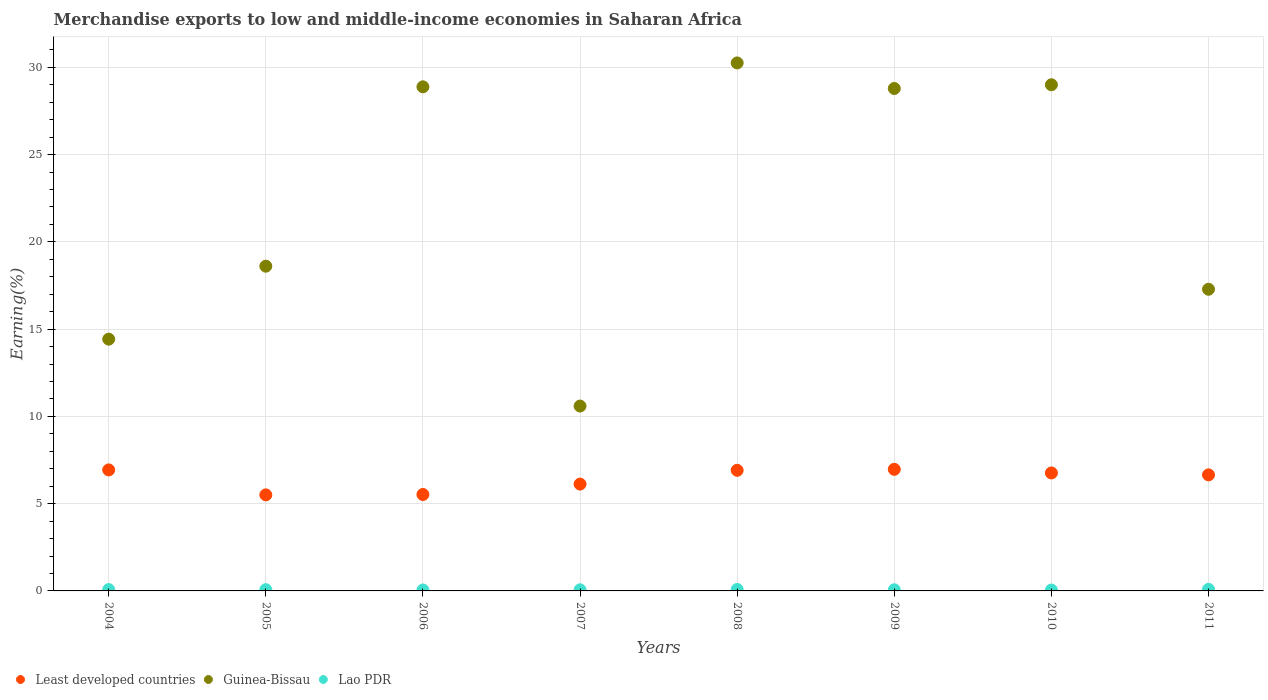What is the percentage of amount earned from merchandise exports in Least developed countries in 2004?
Keep it short and to the point. 6.93. Across all years, what is the maximum percentage of amount earned from merchandise exports in Least developed countries?
Your answer should be compact. 6.97. Across all years, what is the minimum percentage of amount earned from merchandise exports in Guinea-Bissau?
Give a very brief answer. 10.59. In which year was the percentage of amount earned from merchandise exports in Lao PDR minimum?
Your answer should be compact. 2010. What is the total percentage of amount earned from merchandise exports in Guinea-Bissau in the graph?
Your response must be concise. 177.85. What is the difference between the percentage of amount earned from merchandise exports in Least developed countries in 2005 and that in 2008?
Your response must be concise. -1.41. What is the difference between the percentage of amount earned from merchandise exports in Lao PDR in 2006 and the percentage of amount earned from merchandise exports in Least developed countries in 2011?
Provide a short and direct response. -6.6. What is the average percentage of amount earned from merchandise exports in Guinea-Bissau per year?
Your response must be concise. 22.23. In the year 2006, what is the difference between the percentage of amount earned from merchandise exports in Guinea-Bissau and percentage of amount earned from merchandise exports in Lao PDR?
Offer a terse response. 28.83. In how many years, is the percentage of amount earned from merchandise exports in Lao PDR greater than 1 %?
Keep it short and to the point. 0. What is the ratio of the percentage of amount earned from merchandise exports in Least developed countries in 2004 to that in 2006?
Offer a very short reply. 1.25. Is the percentage of amount earned from merchandise exports in Least developed countries in 2006 less than that in 2008?
Provide a succinct answer. Yes. What is the difference between the highest and the second highest percentage of amount earned from merchandise exports in Guinea-Bissau?
Provide a short and direct response. 1.25. What is the difference between the highest and the lowest percentage of amount earned from merchandise exports in Guinea-Bissau?
Give a very brief answer. 19.66. In how many years, is the percentage of amount earned from merchandise exports in Guinea-Bissau greater than the average percentage of amount earned from merchandise exports in Guinea-Bissau taken over all years?
Your answer should be very brief. 4. Does the percentage of amount earned from merchandise exports in Least developed countries monotonically increase over the years?
Ensure brevity in your answer.  No. How many years are there in the graph?
Keep it short and to the point. 8. What is the difference between two consecutive major ticks on the Y-axis?
Provide a short and direct response. 5. Are the values on the major ticks of Y-axis written in scientific E-notation?
Keep it short and to the point. No. Does the graph contain any zero values?
Provide a short and direct response. No. Where does the legend appear in the graph?
Offer a terse response. Bottom left. How many legend labels are there?
Provide a short and direct response. 3. What is the title of the graph?
Your response must be concise. Merchandise exports to low and middle-income economies in Saharan Africa. Does "Sub-Saharan Africa (developing only)" appear as one of the legend labels in the graph?
Your response must be concise. No. What is the label or title of the Y-axis?
Ensure brevity in your answer.  Earning(%). What is the Earning(%) of Least developed countries in 2004?
Make the answer very short. 6.93. What is the Earning(%) of Guinea-Bissau in 2004?
Your answer should be compact. 14.43. What is the Earning(%) of Lao PDR in 2004?
Provide a succinct answer. 0.08. What is the Earning(%) in Least developed countries in 2005?
Your answer should be compact. 5.5. What is the Earning(%) in Guinea-Bissau in 2005?
Your answer should be compact. 18.61. What is the Earning(%) of Lao PDR in 2005?
Offer a very short reply. 0.07. What is the Earning(%) of Least developed countries in 2006?
Your answer should be compact. 5.53. What is the Earning(%) of Guinea-Bissau in 2006?
Your answer should be compact. 28.89. What is the Earning(%) in Lao PDR in 2006?
Your answer should be very brief. 0.05. What is the Earning(%) in Least developed countries in 2007?
Provide a succinct answer. 6.12. What is the Earning(%) in Guinea-Bissau in 2007?
Give a very brief answer. 10.59. What is the Earning(%) in Lao PDR in 2007?
Make the answer very short. 0.06. What is the Earning(%) of Least developed countries in 2008?
Offer a very short reply. 6.91. What is the Earning(%) in Guinea-Bissau in 2008?
Your response must be concise. 30.25. What is the Earning(%) in Lao PDR in 2008?
Your response must be concise. 0.08. What is the Earning(%) of Least developed countries in 2009?
Your response must be concise. 6.97. What is the Earning(%) of Guinea-Bissau in 2009?
Make the answer very short. 28.79. What is the Earning(%) of Lao PDR in 2009?
Keep it short and to the point. 0.07. What is the Earning(%) of Least developed countries in 2010?
Your answer should be very brief. 6.76. What is the Earning(%) in Guinea-Bissau in 2010?
Offer a terse response. 29. What is the Earning(%) in Lao PDR in 2010?
Provide a succinct answer. 0.05. What is the Earning(%) in Least developed countries in 2011?
Give a very brief answer. 6.65. What is the Earning(%) of Guinea-Bissau in 2011?
Keep it short and to the point. 17.29. What is the Earning(%) of Lao PDR in 2011?
Make the answer very short. 0.09. Across all years, what is the maximum Earning(%) in Least developed countries?
Give a very brief answer. 6.97. Across all years, what is the maximum Earning(%) in Guinea-Bissau?
Provide a short and direct response. 30.25. Across all years, what is the maximum Earning(%) of Lao PDR?
Give a very brief answer. 0.09. Across all years, what is the minimum Earning(%) of Least developed countries?
Offer a terse response. 5.5. Across all years, what is the minimum Earning(%) of Guinea-Bissau?
Offer a very short reply. 10.59. Across all years, what is the minimum Earning(%) in Lao PDR?
Make the answer very short. 0.05. What is the total Earning(%) of Least developed countries in the graph?
Make the answer very short. 51.38. What is the total Earning(%) of Guinea-Bissau in the graph?
Make the answer very short. 177.85. What is the total Earning(%) of Lao PDR in the graph?
Offer a very short reply. 0.56. What is the difference between the Earning(%) in Least developed countries in 2004 and that in 2005?
Ensure brevity in your answer.  1.43. What is the difference between the Earning(%) in Guinea-Bissau in 2004 and that in 2005?
Keep it short and to the point. -4.18. What is the difference between the Earning(%) in Lao PDR in 2004 and that in 2005?
Your response must be concise. 0. What is the difference between the Earning(%) of Least developed countries in 2004 and that in 2006?
Your answer should be compact. 1.41. What is the difference between the Earning(%) of Guinea-Bissau in 2004 and that in 2006?
Ensure brevity in your answer.  -14.46. What is the difference between the Earning(%) in Lao PDR in 2004 and that in 2006?
Offer a very short reply. 0.02. What is the difference between the Earning(%) of Least developed countries in 2004 and that in 2007?
Your answer should be very brief. 0.81. What is the difference between the Earning(%) in Guinea-Bissau in 2004 and that in 2007?
Provide a succinct answer. 3.83. What is the difference between the Earning(%) in Lao PDR in 2004 and that in 2007?
Provide a succinct answer. 0.01. What is the difference between the Earning(%) in Least developed countries in 2004 and that in 2008?
Make the answer very short. 0.02. What is the difference between the Earning(%) of Guinea-Bissau in 2004 and that in 2008?
Your answer should be very brief. -15.83. What is the difference between the Earning(%) in Lao PDR in 2004 and that in 2008?
Make the answer very short. -0.01. What is the difference between the Earning(%) of Least developed countries in 2004 and that in 2009?
Give a very brief answer. -0.03. What is the difference between the Earning(%) in Guinea-Bissau in 2004 and that in 2009?
Your answer should be compact. -14.36. What is the difference between the Earning(%) in Lao PDR in 2004 and that in 2009?
Your answer should be compact. 0.01. What is the difference between the Earning(%) in Least developed countries in 2004 and that in 2010?
Give a very brief answer. 0.17. What is the difference between the Earning(%) of Guinea-Bissau in 2004 and that in 2010?
Your answer should be compact. -14.58. What is the difference between the Earning(%) in Lao PDR in 2004 and that in 2010?
Keep it short and to the point. 0.03. What is the difference between the Earning(%) in Least developed countries in 2004 and that in 2011?
Keep it short and to the point. 0.28. What is the difference between the Earning(%) of Guinea-Bissau in 2004 and that in 2011?
Your answer should be compact. -2.86. What is the difference between the Earning(%) of Lao PDR in 2004 and that in 2011?
Ensure brevity in your answer.  -0.01. What is the difference between the Earning(%) in Least developed countries in 2005 and that in 2006?
Offer a terse response. -0.02. What is the difference between the Earning(%) of Guinea-Bissau in 2005 and that in 2006?
Ensure brevity in your answer.  -10.28. What is the difference between the Earning(%) of Lao PDR in 2005 and that in 2006?
Provide a short and direct response. 0.02. What is the difference between the Earning(%) in Least developed countries in 2005 and that in 2007?
Your response must be concise. -0.62. What is the difference between the Earning(%) of Guinea-Bissau in 2005 and that in 2007?
Your answer should be very brief. 8.01. What is the difference between the Earning(%) in Lao PDR in 2005 and that in 2007?
Give a very brief answer. 0.01. What is the difference between the Earning(%) of Least developed countries in 2005 and that in 2008?
Make the answer very short. -1.41. What is the difference between the Earning(%) in Guinea-Bissau in 2005 and that in 2008?
Make the answer very short. -11.65. What is the difference between the Earning(%) of Lao PDR in 2005 and that in 2008?
Keep it short and to the point. -0.01. What is the difference between the Earning(%) of Least developed countries in 2005 and that in 2009?
Ensure brevity in your answer.  -1.46. What is the difference between the Earning(%) of Guinea-Bissau in 2005 and that in 2009?
Your response must be concise. -10.18. What is the difference between the Earning(%) of Lao PDR in 2005 and that in 2009?
Offer a terse response. 0.01. What is the difference between the Earning(%) in Least developed countries in 2005 and that in 2010?
Offer a very short reply. -1.26. What is the difference between the Earning(%) in Guinea-Bissau in 2005 and that in 2010?
Your response must be concise. -10.4. What is the difference between the Earning(%) of Lao PDR in 2005 and that in 2010?
Make the answer very short. 0.02. What is the difference between the Earning(%) of Least developed countries in 2005 and that in 2011?
Offer a terse response. -1.15. What is the difference between the Earning(%) of Guinea-Bissau in 2005 and that in 2011?
Ensure brevity in your answer.  1.32. What is the difference between the Earning(%) of Lao PDR in 2005 and that in 2011?
Provide a succinct answer. -0.02. What is the difference between the Earning(%) of Least developed countries in 2006 and that in 2007?
Keep it short and to the point. -0.6. What is the difference between the Earning(%) of Guinea-Bissau in 2006 and that in 2007?
Offer a very short reply. 18.29. What is the difference between the Earning(%) of Lao PDR in 2006 and that in 2007?
Keep it short and to the point. -0.01. What is the difference between the Earning(%) of Least developed countries in 2006 and that in 2008?
Your answer should be very brief. -1.39. What is the difference between the Earning(%) of Guinea-Bissau in 2006 and that in 2008?
Your answer should be very brief. -1.37. What is the difference between the Earning(%) in Lao PDR in 2006 and that in 2008?
Your answer should be compact. -0.03. What is the difference between the Earning(%) of Least developed countries in 2006 and that in 2009?
Offer a very short reply. -1.44. What is the difference between the Earning(%) in Guinea-Bissau in 2006 and that in 2009?
Ensure brevity in your answer.  0.09. What is the difference between the Earning(%) in Lao PDR in 2006 and that in 2009?
Your response must be concise. -0.01. What is the difference between the Earning(%) in Least developed countries in 2006 and that in 2010?
Make the answer very short. -1.23. What is the difference between the Earning(%) of Guinea-Bissau in 2006 and that in 2010?
Ensure brevity in your answer.  -0.12. What is the difference between the Earning(%) in Lao PDR in 2006 and that in 2010?
Give a very brief answer. 0. What is the difference between the Earning(%) in Least developed countries in 2006 and that in 2011?
Your response must be concise. -1.12. What is the difference between the Earning(%) of Guinea-Bissau in 2006 and that in 2011?
Your response must be concise. 11.6. What is the difference between the Earning(%) in Lao PDR in 2006 and that in 2011?
Ensure brevity in your answer.  -0.04. What is the difference between the Earning(%) of Least developed countries in 2007 and that in 2008?
Provide a short and direct response. -0.79. What is the difference between the Earning(%) of Guinea-Bissau in 2007 and that in 2008?
Your answer should be very brief. -19.66. What is the difference between the Earning(%) in Lao PDR in 2007 and that in 2008?
Your answer should be very brief. -0.02. What is the difference between the Earning(%) in Least developed countries in 2007 and that in 2009?
Keep it short and to the point. -0.85. What is the difference between the Earning(%) in Guinea-Bissau in 2007 and that in 2009?
Offer a very short reply. -18.2. What is the difference between the Earning(%) in Lao PDR in 2007 and that in 2009?
Offer a very short reply. -0. What is the difference between the Earning(%) of Least developed countries in 2007 and that in 2010?
Provide a succinct answer. -0.64. What is the difference between the Earning(%) in Guinea-Bissau in 2007 and that in 2010?
Offer a terse response. -18.41. What is the difference between the Earning(%) in Lao PDR in 2007 and that in 2010?
Offer a very short reply. 0.01. What is the difference between the Earning(%) in Least developed countries in 2007 and that in 2011?
Keep it short and to the point. -0.53. What is the difference between the Earning(%) of Guinea-Bissau in 2007 and that in 2011?
Give a very brief answer. -6.69. What is the difference between the Earning(%) of Lao PDR in 2007 and that in 2011?
Provide a short and direct response. -0.03. What is the difference between the Earning(%) in Least developed countries in 2008 and that in 2009?
Keep it short and to the point. -0.06. What is the difference between the Earning(%) of Guinea-Bissau in 2008 and that in 2009?
Offer a terse response. 1.46. What is the difference between the Earning(%) in Lao PDR in 2008 and that in 2009?
Ensure brevity in your answer.  0.02. What is the difference between the Earning(%) of Least developed countries in 2008 and that in 2010?
Offer a very short reply. 0.15. What is the difference between the Earning(%) of Guinea-Bissau in 2008 and that in 2010?
Ensure brevity in your answer.  1.25. What is the difference between the Earning(%) of Lao PDR in 2008 and that in 2010?
Your answer should be compact. 0.03. What is the difference between the Earning(%) in Least developed countries in 2008 and that in 2011?
Your answer should be very brief. 0.26. What is the difference between the Earning(%) in Guinea-Bissau in 2008 and that in 2011?
Give a very brief answer. 12.97. What is the difference between the Earning(%) of Lao PDR in 2008 and that in 2011?
Provide a short and direct response. -0.01. What is the difference between the Earning(%) of Least developed countries in 2009 and that in 2010?
Your answer should be compact. 0.21. What is the difference between the Earning(%) of Guinea-Bissau in 2009 and that in 2010?
Ensure brevity in your answer.  -0.21. What is the difference between the Earning(%) of Lao PDR in 2009 and that in 2010?
Your response must be concise. 0.02. What is the difference between the Earning(%) of Least developed countries in 2009 and that in 2011?
Offer a very short reply. 0.32. What is the difference between the Earning(%) of Guinea-Bissau in 2009 and that in 2011?
Keep it short and to the point. 11.5. What is the difference between the Earning(%) in Lao PDR in 2009 and that in 2011?
Provide a short and direct response. -0.03. What is the difference between the Earning(%) in Least developed countries in 2010 and that in 2011?
Your answer should be very brief. 0.11. What is the difference between the Earning(%) in Guinea-Bissau in 2010 and that in 2011?
Your answer should be compact. 11.72. What is the difference between the Earning(%) in Lao PDR in 2010 and that in 2011?
Your answer should be very brief. -0.04. What is the difference between the Earning(%) of Least developed countries in 2004 and the Earning(%) of Guinea-Bissau in 2005?
Your answer should be compact. -11.67. What is the difference between the Earning(%) in Least developed countries in 2004 and the Earning(%) in Lao PDR in 2005?
Your answer should be very brief. 6.86. What is the difference between the Earning(%) of Guinea-Bissau in 2004 and the Earning(%) of Lao PDR in 2005?
Keep it short and to the point. 14.35. What is the difference between the Earning(%) in Least developed countries in 2004 and the Earning(%) in Guinea-Bissau in 2006?
Provide a succinct answer. -21.95. What is the difference between the Earning(%) of Least developed countries in 2004 and the Earning(%) of Lao PDR in 2006?
Make the answer very short. 6.88. What is the difference between the Earning(%) in Guinea-Bissau in 2004 and the Earning(%) in Lao PDR in 2006?
Give a very brief answer. 14.37. What is the difference between the Earning(%) in Least developed countries in 2004 and the Earning(%) in Guinea-Bissau in 2007?
Give a very brief answer. -3.66. What is the difference between the Earning(%) of Least developed countries in 2004 and the Earning(%) of Lao PDR in 2007?
Offer a very short reply. 6.87. What is the difference between the Earning(%) of Guinea-Bissau in 2004 and the Earning(%) of Lao PDR in 2007?
Ensure brevity in your answer.  14.36. What is the difference between the Earning(%) of Least developed countries in 2004 and the Earning(%) of Guinea-Bissau in 2008?
Make the answer very short. -23.32. What is the difference between the Earning(%) in Least developed countries in 2004 and the Earning(%) in Lao PDR in 2008?
Your answer should be very brief. 6.85. What is the difference between the Earning(%) of Guinea-Bissau in 2004 and the Earning(%) of Lao PDR in 2008?
Make the answer very short. 14.34. What is the difference between the Earning(%) in Least developed countries in 2004 and the Earning(%) in Guinea-Bissau in 2009?
Ensure brevity in your answer.  -21.86. What is the difference between the Earning(%) in Least developed countries in 2004 and the Earning(%) in Lao PDR in 2009?
Offer a very short reply. 6.87. What is the difference between the Earning(%) in Guinea-Bissau in 2004 and the Earning(%) in Lao PDR in 2009?
Ensure brevity in your answer.  14.36. What is the difference between the Earning(%) of Least developed countries in 2004 and the Earning(%) of Guinea-Bissau in 2010?
Your response must be concise. -22.07. What is the difference between the Earning(%) in Least developed countries in 2004 and the Earning(%) in Lao PDR in 2010?
Provide a succinct answer. 6.88. What is the difference between the Earning(%) of Guinea-Bissau in 2004 and the Earning(%) of Lao PDR in 2010?
Your response must be concise. 14.38. What is the difference between the Earning(%) of Least developed countries in 2004 and the Earning(%) of Guinea-Bissau in 2011?
Your answer should be very brief. -10.35. What is the difference between the Earning(%) in Least developed countries in 2004 and the Earning(%) in Lao PDR in 2011?
Offer a very short reply. 6.84. What is the difference between the Earning(%) in Guinea-Bissau in 2004 and the Earning(%) in Lao PDR in 2011?
Provide a short and direct response. 14.34. What is the difference between the Earning(%) of Least developed countries in 2005 and the Earning(%) of Guinea-Bissau in 2006?
Your response must be concise. -23.38. What is the difference between the Earning(%) of Least developed countries in 2005 and the Earning(%) of Lao PDR in 2006?
Your response must be concise. 5.45. What is the difference between the Earning(%) in Guinea-Bissau in 2005 and the Earning(%) in Lao PDR in 2006?
Provide a short and direct response. 18.55. What is the difference between the Earning(%) in Least developed countries in 2005 and the Earning(%) in Guinea-Bissau in 2007?
Your response must be concise. -5.09. What is the difference between the Earning(%) of Least developed countries in 2005 and the Earning(%) of Lao PDR in 2007?
Your answer should be compact. 5.44. What is the difference between the Earning(%) of Guinea-Bissau in 2005 and the Earning(%) of Lao PDR in 2007?
Your answer should be compact. 18.54. What is the difference between the Earning(%) of Least developed countries in 2005 and the Earning(%) of Guinea-Bissau in 2008?
Your response must be concise. -24.75. What is the difference between the Earning(%) in Least developed countries in 2005 and the Earning(%) in Lao PDR in 2008?
Your response must be concise. 5.42. What is the difference between the Earning(%) in Guinea-Bissau in 2005 and the Earning(%) in Lao PDR in 2008?
Offer a very short reply. 18.52. What is the difference between the Earning(%) of Least developed countries in 2005 and the Earning(%) of Guinea-Bissau in 2009?
Offer a very short reply. -23.29. What is the difference between the Earning(%) of Least developed countries in 2005 and the Earning(%) of Lao PDR in 2009?
Ensure brevity in your answer.  5.44. What is the difference between the Earning(%) of Guinea-Bissau in 2005 and the Earning(%) of Lao PDR in 2009?
Your answer should be very brief. 18.54. What is the difference between the Earning(%) in Least developed countries in 2005 and the Earning(%) in Guinea-Bissau in 2010?
Your answer should be very brief. -23.5. What is the difference between the Earning(%) of Least developed countries in 2005 and the Earning(%) of Lao PDR in 2010?
Make the answer very short. 5.45. What is the difference between the Earning(%) in Guinea-Bissau in 2005 and the Earning(%) in Lao PDR in 2010?
Your answer should be very brief. 18.56. What is the difference between the Earning(%) in Least developed countries in 2005 and the Earning(%) in Guinea-Bissau in 2011?
Give a very brief answer. -11.78. What is the difference between the Earning(%) of Least developed countries in 2005 and the Earning(%) of Lao PDR in 2011?
Provide a succinct answer. 5.41. What is the difference between the Earning(%) in Guinea-Bissau in 2005 and the Earning(%) in Lao PDR in 2011?
Your answer should be compact. 18.52. What is the difference between the Earning(%) in Least developed countries in 2006 and the Earning(%) in Guinea-Bissau in 2007?
Provide a short and direct response. -5.07. What is the difference between the Earning(%) in Least developed countries in 2006 and the Earning(%) in Lao PDR in 2007?
Keep it short and to the point. 5.46. What is the difference between the Earning(%) in Guinea-Bissau in 2006 and the Earning(%) in Lao PDR in 2007?
Your answer should be very brief. 28.82. What is the difference between the Earning(%) of Least developed countries in 2006 and the Earning(%) of Guinea-Bissau in 2008?
Your response must be concise. -24.73. What is the difference between the Earning(%) of Least developed countries in 2006 and the Earning(%) of Lao PDR in 2008?
Offer a very short reply. 5.44. What is the difference between the Earning(%) in Guinea-Bissau in 2006 and the Earning(%) in Lao PDR in 2008?
Your response must be concise. 28.8. What is the difference between the Earning(%) of Least developed countries in 2006 and the Earning(%) of Guinea-Bissau in 2009?
Your answer should be compact. -23.27. What is the difference between the Earning(%) of Least developed countries in 2006 and the Earning(%) of Lao PDR in 2009?
Your response must be concise. 5.46. What is the difference between the Earning(%) of Guinea-Bissau in 2006 and the Earning(%) of Lao PDR in 2009?
Provide a short and direct response. 28.82. What is the difference between the Earning(%) of Least developed countries in 2006 and the Earning(%) of Guinea-Bissau in 2010?
Provide a succinct answer. -23.48. What is the difference between the Earning(%) of Least developed countries in 2006 and the Earning(%) of Lao PDR in 2010?
Provide a short and direct response. 5.48. What is the difference between the Earning(%) in Guinea-Bissau in 2006 and the Earning(%) in Lao PDR in 2010?
Your answer should be very brief. 28.83. What is the difference between the Earning(%) of Least developed countries in 2006 and the Earning(%) of Guinea-Bissau in 2011?
Your answer should be compact. -11.76. What is the difference between the Earning(%) in Least developed countries in 2006 and the Earning(%) in Lao PDR in 2011?
Your answer should be compact. 5.43. What is the difference between the Earning(%) of Guinea-Bissau in 2006 and the Earning(%) of Lao PDR in 2011?
Your answer should be very brief. 28.79. What is the difference between the Earning(%) in Least developed countries in 2007 and the Earning(%) in Guinea-Bissau in 2008?
Offer a very short reply. -24.13. What is the difference between the Earning(%) of Least developed countries in 2007 and the Earning(%) of Lao PDR in 2008?
Offer a very short reply. 6.04. What is the difference between the Earning(%) of Guinea-Bissau in 2007 and the Earning(%) of Lao PDR in 2008?
Make the answer very short. 10.51. What is the difference between the Earning(%) of Least developed countries in 2007 and the Earning(%) of Guinea-Bissau in 2009?
Give a very brief answer. -22.67. What is the difference between the Earning(%) in Least developed countries in 2007 and the Earning(%) in Lao PDR in 2009?
Ensure brevity in your answer.  6.06. What is the difference between the Earning(%) in Guinea-Bissau in 2007 and the Earning(%) in Lao PDR in 2009?
Your answer should be very brief. 10.53. What is the difference between the Earning(%) of Least developed countries in 2007 and the Earning(%) of Guinea-Bissau in 2010?
Provide a short and direct response. -22.88. What is the difference between the Earning(%) in Least developed countries in 2007 and the Earning(%) in Lao PDR in 2010?
Provide a succinct answer. 6.07. What is the difference between the Earning(%) in Guinea-Bissau in 2007 and the Earning(%) in Lao PDR in 2010?
Your answer should be very brief. 10.54. What is the difference between the Earning(%) of Least developed countries in 2007 and the Earning(%) of Guinea-Bissau in 2011?
Your answer should be compact. -11.16. What is the difference between the Earning(%) of Least developed countries in 2007 and the Earning(%) of Lao PDR in 2011?
Provide a succinct answer. 6.03. What is the difference between the Earning(%) in Guinea-Bissau in 2007 and the Earning(%) in Lao PDR in 2011?
Provide a short and direct response. 10.5. What is the difference between the Earning(%) in Least developed countries in 2008 and the Earning(%) in Guinea-Bissau in 2009?
Your answer should be compact. -21.88. What is the difference between the Earning(%) in Least developed countries in 2008 and the Earning(%) in Lao PDR in 2009?
Offer a very short reply. 6.85. What is the difference between the Earning(%) of Guinea-Bissau in 2008 and the Earning(%) of Lao PDR in 2009?
Make the answer very short. 30.19. What is the difference between the Earning(%) in Least developed countries in 2008 and the Earning(%) in Guinea-Bissau in 2010?
Your answer should be very brief. -22.09. What is the difference between the Earning(%) in Least developed countries in 2008 and the Earning(%) in Lao PDR in 2010?
Provide a succinct answer. 6.86. What is the difference between the Earning(%) in Guinea-Bissau in 2008 and the Earning(%) in Lao PDR in 2010?
Keep it short and to the point. 30.2. What is the difference between the Earning(%) in Least developed countries in 2008 and the Earning(%) in Guinea-Bissau in 2011?
Provide a succinct answer. -10.38. What is the difference between the Earning(%) of Least developed countries in 2008 and the Earning(%) of Lao PDR in 2011?
Offer a very short reply. 6.82. What is the difference between the Earning(%) in Guinea-Bissau in 2008 and the Earning(%) in Lao PDR in 2011?
Keep it short and to the point. 30.16. What is the difference between the Earning(%) of Least developed countries in 2009 and the Earning(%) of Guinea-Bissau in 2010?
Your answer should be compact. -22.04. What is the difference between the Earning(%) of Least developed countries in 2009 and the Earning(%) of Lao PDR in 2010?
Your answer should be compact. 6.92. What is the difference between the Earning(%) of Guinea-Bissau in 2009 and the Earning(%) of Lao PDR in 2010?
Keep it short and to the point. 28.74. What is the difference between the Earning(%) of Least developed countries in 2009 and the Earning(%) of Guinea-Bissau in 2011?
Make the answer very short. -10.32. What is the difference between the Earning(%) of Least developed countries in 2009 and the Earning(%) of Lao PDR in 2011?
Make the answer very short. 6.88. What is the difference between the Earning(%) of Guinea-Bissau in 2009 and the Earning(%) of Lao PDR in 2011?
Your answer should be very brief. 28.7. What is the difference between the Earning(%) of Least developed countries in 2010 and the Earning(%) of Guinea-Bissau in 2011?
Provide a succinct answer. -10.53. What is the difference between the Earning(%) in Least developed countries in 2010 and the Earning(%) in Lao PDR in 2011?
Offer a terse response. 6.67. What is the difference between the Earning(%) of Guinea-Bissau in 2010 and the Earning(%) of Lao PDR in 2011?
Offer a terse response. 28.91. What is the average Earning(%) of Least developed countries per year?
Make the answer very short. 6.42. What is the average Earning(%) in Guinea-Bissau per year?
Your response must be concise. 22.23. What is the average Earning(%) in Lao PDR per year?
Provide a succinct answer. 0.07. In the year 2004, what is the difference between the Earning(%) of Least developed countries and Earning(%) of Guinea-Bissau?
Offer a terse response. -7.49. In the year 2004, what is the difference between the Earning(%) in Least developed countries and Earning(%) in Lao PDR?
Provide a succinct answer. 6.86. In the year 2004, what is the difference between the Earning(%) of Guinea-Bissau and Earning(%) of Lao PDR?
Your answer should be compact. 14.35. In the year 2005, what is the difference between the Earning(%) in Least developed countries and Earning(%) in Guinea-Bissau?
Offer a terse response. -13.1. In the year 2005, what is the difference between the Earning(%) in Least developed countries and Earning(%) in Lao PDR?
Offer a terse response. 5.43. In the year 2005, what is the difference between the Earning(%) of Guinea-Bissau and Earning(%) of Lao PDR?
Your response must be concise. 18.54. In the year 2006, what is the difference between the Earning(%) of Least developed countries and Earning(%) of Guinea-Bissau?
Ensure brevity in your answer.  -23.36. In the year 2006, what is the difference between the Earning(%) in Least developed countries and Earning(%) in Lao PDR?
Provide a short and direct response. 5.47. In the year 2006, what is the difference between the Earning(%) in Guinea-Bissau and Earning(%) in Lao PDR?
Provide a succinct answer. 28.83. In the year 2007, what is the difference between the Earning(%) in Least developed countries and Earning(%) in Guinea-Bissau?
Your answer should be very brief. -4.47. In the year 2007, what is the difference between the Earning(%) of Least developed countries and Earning(%) of Lao PDR?
Offer a very short reply. 6.06. In the year 2007, what is the difference between the Earning(%) in Guinea-Bissau and Earning(%) in Lao PDR?
Your answer should be very brief. 10.53. In the year 2008, what is the difference between the Earning(%) in Least developed countries and Earning(%) in Guinea-Bissau?
Keep it short and to the point. -23.34. In the year 2008, what is the difference between the Earning(%) in Least developed countries and Earning(%) in Lao PDR?
Your response must be concise. 6.83. In the year 2008, what is the difference between the Earning(%) of Guinea-Bissau and Earning(%) of Lao PDR?
Offer a very short reply. 30.17. In the year 2009, what is the difference between the Earning(%) of Least developed countries and Earning(%) of Guinea-Bissau?
Provide a short and direct response. -21.82. In the year 2009, what is the difference between the Earning(%) of Least developed countries and Earning(%) of Lao PDR?
Your answer should be very brief. 6.9. In the year 2009, what is the difference between the Earning(%) in Guinea-Bissau and Earning(%) in Lao PDR?
Your answer should be very brief. 28.73. In the year 2010, what is the difference between the Earning(%) in Least developed countries and Earning(%) in Guinea-Bissau?
Provide a short and direct response. -22.24. In the year 2010, what is the difference between the Earning(%) in Least developed countries and Earning(%) in Lao PDR?
Provide a succinct answer. 6.71. In the year 2010, what is the difference between the Earning(%) in Guinea-Bissau and Earning(%) in Lao PDR?
Give a very brief answer. 28.95. In the year 2011, what is the difference between the Earning(%) of Least developed countries and Earning(%) of Guinea-Bissau?
Offer a very short reply. -10.64. In the year 2011, what is the difference between the Earning(%) in Least developed countries and Earning(%) in Lao PDR?
Offer a very short reply. 6.56. In the year 2011, what is the difference between the Earning(%) in Guinea-Bissau and Earning(%) in Lao PDR?
Keep it short and to the point. 17.2. What is the ratio of the Earning(%) of Least developed countries in 2004 to that in 2005?
Keep it short and to the point. 1.26. What is the ratio of the Earning(%) of Guinea-Bissau in 2004 to that in 2005?
Your answer should be very brief. 0.78. What is the ratio of the Earning(%) of Lao PDR in 2004 to that in 2005?
Provide a succinct answer. 1.07. What is the ratio of the Earning(%) in Least developed countries in 2004 to that in 2006?
Your response must be concise. 1.25. What is the ratio of the Earning(%) in Guinea-Bissau in 2004 to that in 2006?
Offer a very short reply. 0.5. What is the ratio of the Earning(%) of Lao PDR in 2004 to that in 2006?
Provide a short and direct response. 1.41. What is the ratio of the Earning(%) of Least developed countries in 2004 to that in 2007?
Your response must be concise. 1.13. What is the ratio of the Earning(%) in Guinea-Bissau in 2004 to that in 2007?
Your response must be concise. 1.36. What is the ratio of the Earning(%) of Lao PDR in 2004 to that in 2007?
Provide a succinct answer. 1.2. What is the ratio of the Earning(%) of Least developed countries in 2004 to that in 2008?
Your answer should be very brief. 1. What is the ratio of the Earning(%) of Guinea-Bissau in 2004 to that in 2008?
Your response must be concise. 0.48. What is the ratio of the Earning(%) in Least developed countries in 2004 to that in 2009?
Make the answer very short. 1. What is the ratio of the Earning(%) in Guinea-Bissau in 2004 to that in 2009?
Make the answer very short. 0.5. What is the ratio of the Earning(%) of Lao PDR in 2004 to that in 2009?
Ensure brevity in your answer.  1.17. What is the ratio of the Earning(%) in Least developed countries in 2004 to that in 2010?
Ensure brevity in your answer.  1.03. What is the ratio of the Earning(%) in Guinea-Bissau in 2004 to that in 2010?
Make the answer very short. 0.5. What is the ratio of the Earning(%) of Lao PDR in 2004 to that in 2010?
Give a very brief answer. 1.52. What is the ratio of the Earning(%) of Least developed countries in 2004 to that in 2011?
Provide a succinct answer. 1.04. What is the ratio of the Earning(%) of Guinea-Bissau in 2004 to that in 2011?
Offer a terse response. 0.83. What is the ratio of the Earning(%) in Lao PDR in 2004 to that in 2011?
Your answer should be compact. 0.84. What is the ratio of the Earning(%) of Least developed countries in 2005 to that in 2006?
Ensure brevity in your answer.  1. What is the ratio of the Earning(%) in Guinea-Bissau in 2005 to that in 2006?
Offer a very short reply. 0.64. What is the ratio of the Earning(%) in Lao PDR in 2005 to that in 2006?
Offer a terse response. 1.32. What is the ratio of the Earning(%) of Least developed countries in 2005 to that in 2007?
Your response must be concise. 0.9. What is the ratio of the Earning(%) in Guinea-Bissau in 2005 to that in 2007?
Keep it short and to the point. 1.76. What is the ratio of the Earning(%) in Lao PDR in 2005 to that in 2007?
Your response must be concise. 1.13. What is the ratio of the Earning(%) of Least developed countries in 2005 to that in 2008?
Give a very brief answer. 0.8. What is the ratio of the Earning(%) of Guinea-Bissau in 2005 to that in 2008?
Your answer should be very brief. 0.61. What is the ratio of the Earning(%) of Lao PDR in 2005 to that in 2008?
Your response must be concise. 0.86. What is the ratio of the Earning(%) in Least developed countries in 2005 to that in 2009?
Offer a very short reply. 0.79. What is the ratio of the Earning(%) of Guinea-Bissau in 2005 to that in 2009?
Offer a terse response. 0.65. What is the ratio of the Earning(%) in Lao PDR in 2005 to that in 2009?
Make the answer very short. 1.09. What is the ratio of the Earning(%) of Least developed countries in 2005 to that in 2010?
Offer a very short reply. 0.81. What is the ratio of the Earning(%) in Guinea-Bissau in 2005 to that in 2010?
Your answer should be compact. 0.64. What is the ratio of the Earning(%) in Lao PDR in 2005 to that in 2010?
Your answer should be compact. 1.42. What is the ratio of the Earning(%) of Least developed countries in 2005 to that in 2011?
Ensure brevity in your answer.  0.83. What is the ratio of the Earning(%) in Guinea-Bissau in 2005 to that in 2011?
Offer a terse response. 1.08. What is the ratio of the Earning(%) of Lao PDR in 2005 to that in 2011?
Make the answer very short. 0.79. What is the ratio of the Earning(%) of Least developed countries in 2006 to that in 2007?
Provide a short and direct response. 0.9. What is the ratio of the Earning(%) of Guinea-Bissau in 2006 to that in 2007?
Ensure brevity in your answer.  2.73. What is the ratio of the Earning(%) of Lao PDR in 2006 to that in 2007?
Your response must be concise. 0.85. What is the ratio of the Earning(%) of Least developed countries in 2006 to that in 2008?
Make the answer very short. 0.8. What is the ratio of the Earning(%) of Guinea-Bissau in 2006 to that in 2008?
Your answer should be compact. 0.95. What is the ratio of the Earning(%) in Lao PDR in 2006 to that in 2008?
Keep it short and to the point. 0.65. What is the ratio of the Earning(%) of Least developed countries in 2006 to that in 2009?
Provide a short and direct response. 0.79. What is the ratio of the Earning(%) in Lao PDR in 2006 to that in 2009?
Give a very brief answer. 0.83. What is the ratio of the Earning(%) in Least developed countries in 2006 to that in 2010?
Offer a very short reply. 0.82. What is the ratio of the Earning(%) in Guinea-Bissau in 2006 to that in 2010?
Provide a succinct answer. 1. What is the ratio of the Earning(%) in Lao PDR in 2006 to that in 2010?
Make the answer very short. 1.08. What is the ratio of the Earning(%) of Least developed countries in 2006 to that in 2011?
Your answer should be very brief. 0.83. What is the ratio of the Earning(%) in Guinea-Bissau in 2006 to that in 2011?
Your answer should be very brief. 1.67. What is the ratio of the Earning(%) in Lao PDR in 2006 to that in 2011?
Keep it short and to the point. 0.6. What is the ratio of the Earning(%) in Least developed countries in 2007 to that in 2008?
Make the answer very short. 0.89. What is the ratio of the Earning(%) of Guinea-Bissau in 2007 to that in 2008?
Keep it short and to the point. 0.35. What is the ratio of the Earning(%) in Lao PDR in 2007 to that in 2008?
Offer a terse response. 0.76. What is the ratio of the Earning(%) in Least developed countries in 2007 to that in 2009?
Ensure brevity in your answer.  0.88. What is the ratio of the Earning(%) in Guinea-Bissau in 2007 to that in 2009?
Keep it short and to the point. 0.37. What is the ratio of the Earning(%) in Lao PDR in 2007 to that in 2009?
Make the answer very short. 0.97. What is the ratio of the Earning(%) in Least developed countries in 2007 to that in 2010?
Make the answer very short. 0.91. What is the ratio of the Earning(%) of Guinea-Bissau in 2007 to that in 2010?
Provide a succinct answer. 0.37. What is the ratio of the Earning(%) in Lao PDR in 2007 to that in 2010?
Keep it short and to the point. 1.26. What is the ratio of the Earning(%) in Least developed countries in 2007 to that in 2011?
Your answer should be compact. 0.92. What is the ratio of the Earning(%) of Guinea-Bissau in 2007 to that in 2011?
Provide a short and direct response. 0.61. What is the ratio of the Earning(%) of Lao PDR in 2007 to that in 2011?
Your answer should be compact. 0.7. What is the ratio of the Earning(%) in Guinea-Bissau in 2008 to that in 2009?
Keep it short and to the point. 1.05. What is the ratio of the Earning(%) in Lao PDR in 2008 to that in 2009?
Keep it short and to the point. 1.28. What is the ratio of the Earning(%) in Least developed countries in 2008 to that in 2010?
Your answer should be very brief. 1.02. What is the ratio of the Earning(%) in Guinea-Bissau in 2008 to that in 2010?
Your answer should be very brief. 1.04. What is the ratio of the Earning(%) of Lao PDR in 2008 to that in 2010?
Ensure brevity in your answer.  1.66. What is the ratio of the Earning(%) in Least developed countries in 2008 to that in 2011?
Keep it short and to the point. 1.04. What is the ratio of the Earning(%) of Guinea-Bissau in 2008 to that in 2011?
Your answer should be compact. 1.75. What is the ratio of the Earning(%) of Lao PDR in 2008 to that in 2011?
Your answer should be very brief. 0.92. What is the ratio of the Earning(%) of Least developed countries in 2009 to that in 2010?
Offer a very short reply. 1.03. What is the ratio of the Earning(%) of Guinea-Bissau in 2009 to that in 2010?
Offer a very short reply. 0.99. What is the ratio of the Earning(%) in Lao PDR in 2009 to that in 2010?
Your answer should be compact. 1.3. What is the ratio of the Earning(%) in Least developed countries in 2009 to that in 2011?
Your answer should be compact. 1.05. What is the ratio of the Earning(%) in Guinea-Bissau in 2009 to that in 2011?
Your answer should be compact. 1.67. What is the ratio of the Earning(%) in Lao PDR in 2009 to that in 2011?
Your response must be concise. 0.72. What is the ratio of the Earning(%) in Least developed countries in 2010 to that in 2011?
Give a very brief answer. 1.02. What is the ratio of the Earning(%) of Guinea-Bissau in 2010 to that in 2011?
Your response must be concise. 1.68. What is the ratio of the Earning(%) in Lao PDR in 2010 to that in 2011?
Provide a short and direct response. 0.55. What is the difference between the highest and the second highest Earning(%) of Least developed countries?
Offer a terse response. 0.03. What is the difference between the highest and the second highest Earning(%) of Guinea-Bissau?
Give a very brief answer. 1.25. What is the difference between the highest and the second highest Earning(%) in Lao PDR?
Give a very brief answer. 0.01. What is the difference between the highest and the lowest Earning(%) in Least developed countries?
Provide a succinct answer. 1.46. What is the difference between the highest and the lowest Earning(%) of Guinea-Bissau?
Offer a very short reply. 19.66. What is the difference between the highest and the lowest Earning(%) of Lao PDR?
Provide a short and direct response. 0.04. 